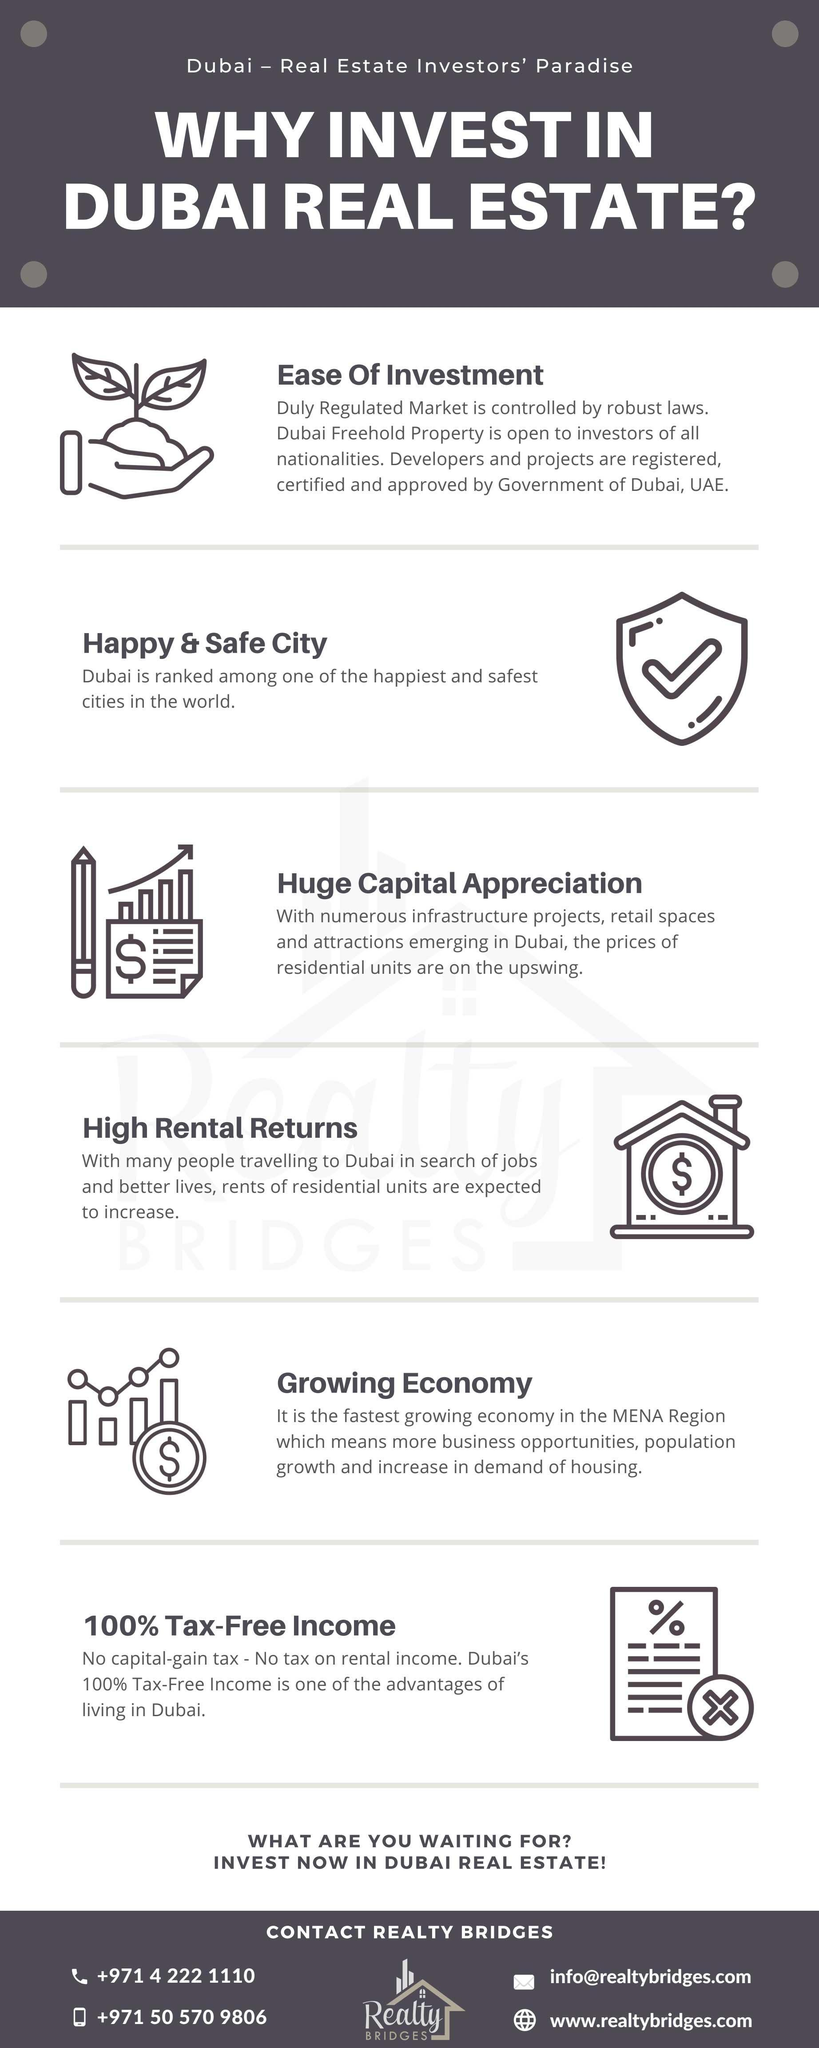What is the mobile number given?
Answer the question with a short phrase. +971 50 570 9806 What is the email ID provided? info@realtybridges.com 